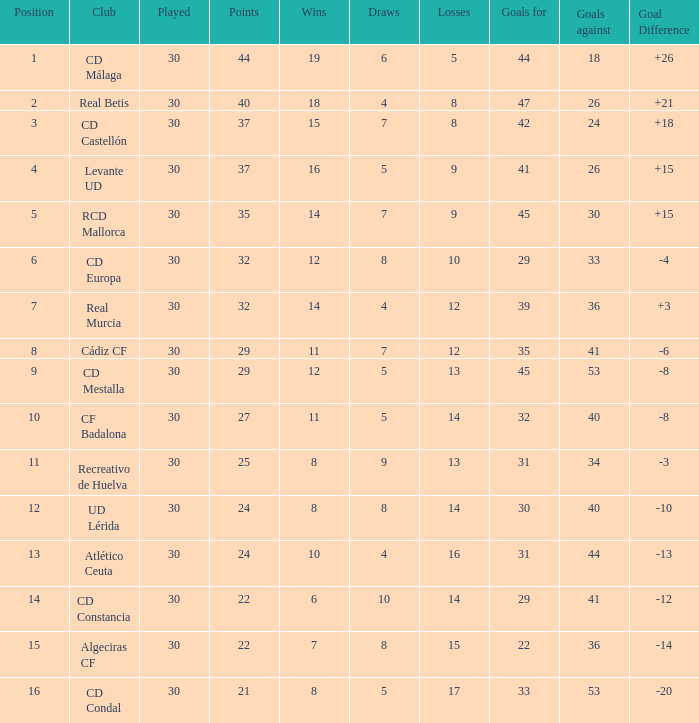When the goal difference was -8 and the position was under 10, what was the total number of losses? 1.0. 